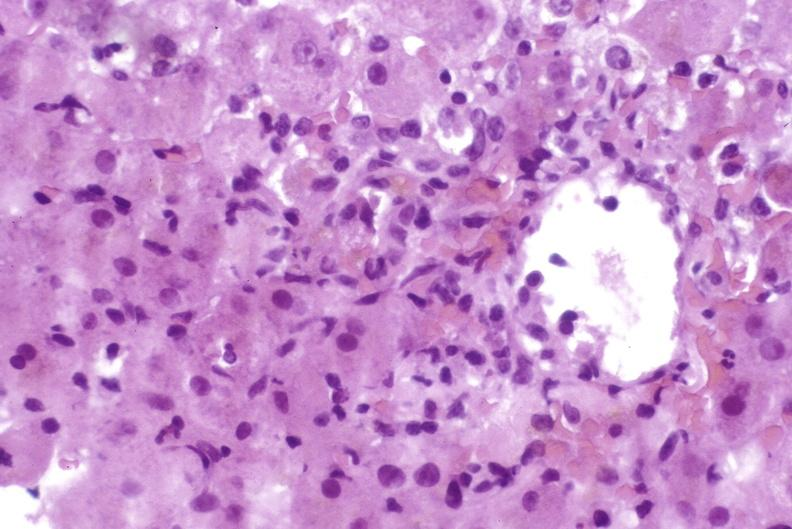s hepatobiliary present?
Answer the question using a single word or phrase. Yes 